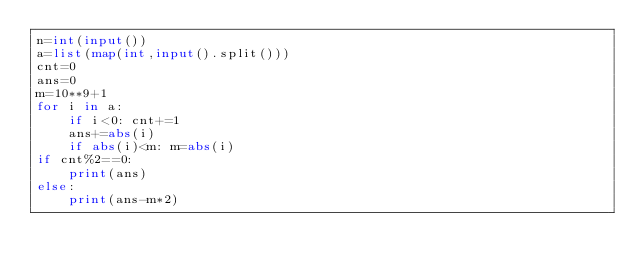Convert code to text. <code><loc_0><loc_0><loc_500><loc_500><_Python_>n=int(input())
a=list(map(int,input().split()))
cnt=0
ans=0
m=10**9+1
for i in a:
    if i<0: cnt+=1
    ans+=abs(i)
    if abs(i)<m: m=abs(i)
if cnt%2==0:
    print(ans)
else:
    print(ans-m*2)</code> 